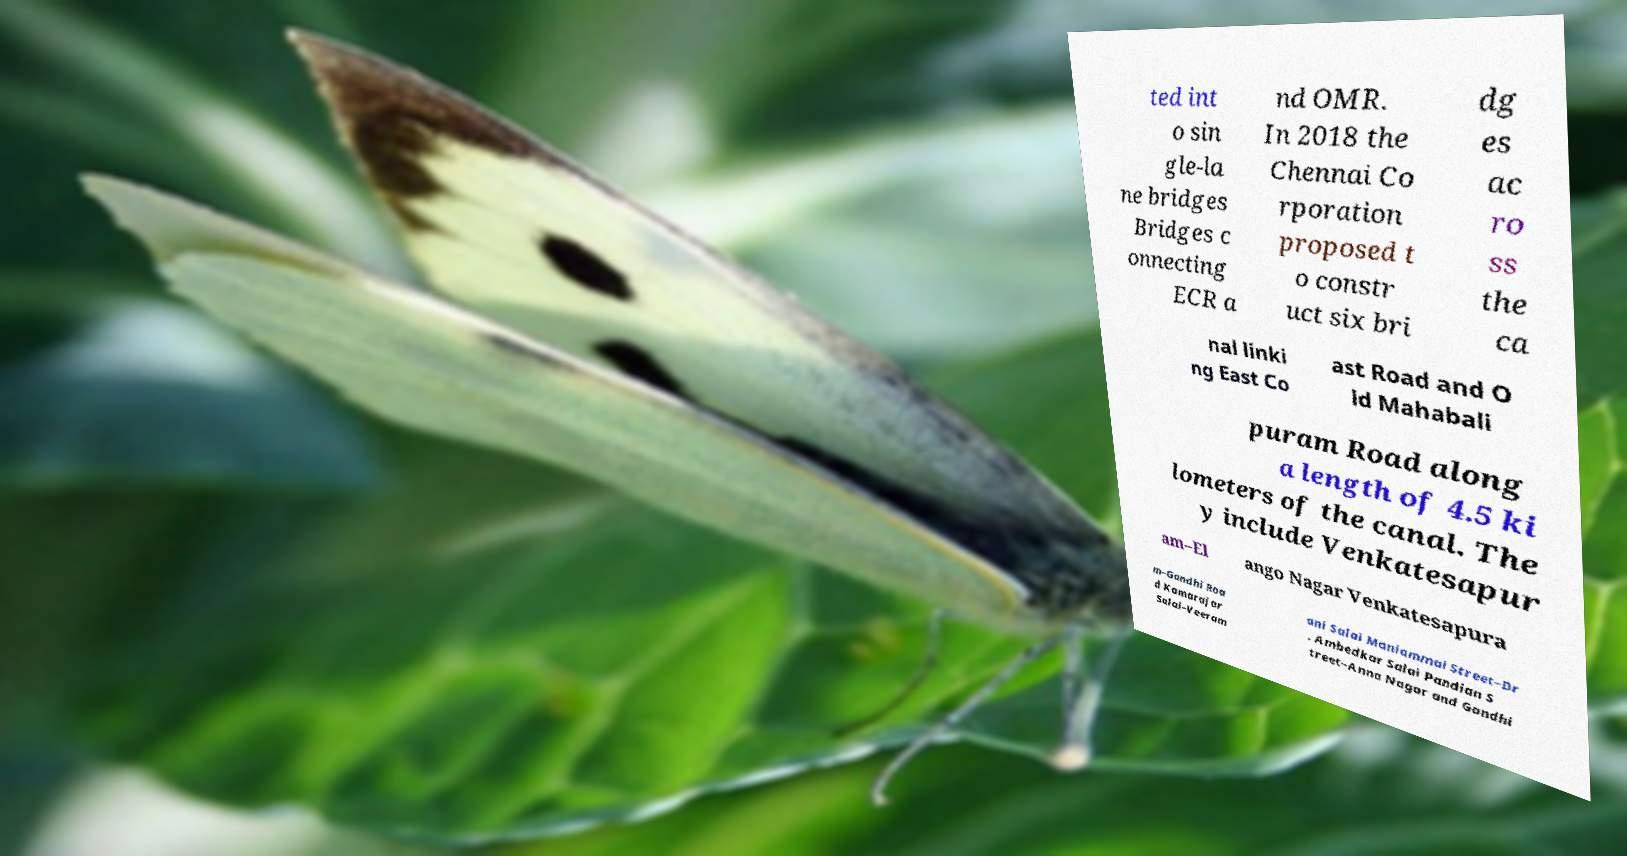Could you extract and type out the text from this image? ted int o sin gle-la ne bridges Bridges c onnecting ECR a nd OMR. In 2018 the Chennai Co rporation proposed t o constr uct six bri dg es ac ro ss the ca nal linki ng East Co ast Road and O ld Mahabali puram Road along a length of 4.5 ki lometers of the canal. The y include Venkatesapur am–El ango Nagar Venkatesapura m–Gandhi Roa d Kamarajar Salai–Veeram ani Salai Maniammai Street–Dr . Ambedkar Salai Pandian S treet–Anna Nagar and Gandhi 